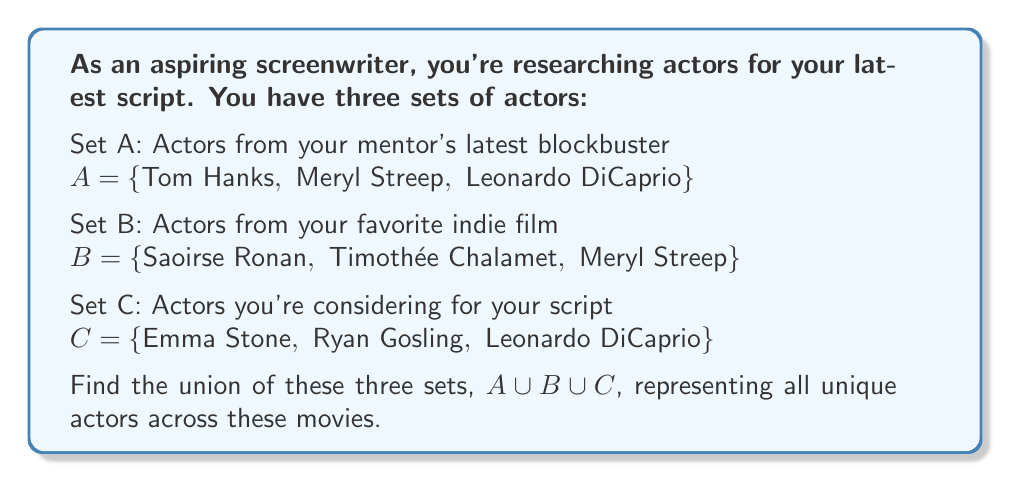Solve this math problem. To find the union of sets A, B, and C, we need to combine all unique elements from these sets. Let's approach this step-by-step:

1. First, let's write out all elements from set A:
   $A = \{$Tom Hanks, Meryl Streep, Leonardo DiCaprio$\}$

2. Now, let's add unique elements from set B:
   - Saoirse Ronan and Timothée Chalamet are new, so we add them.
   - Meryl Streep is already included from set A, so we don't add her again.

3. Finally, let's add unique elements from set C:
   - Emma Stone and Ryan Gosling are new, so we add them.
   - Leonardo DiCaprio is already included from set A, so we don't add him again.

4. The resulting union set contains all unique actors from A, B, and C:

   $A \cup B \cup C = \{$Tom Hanks, Meryl Streep, Leonardo DiCaprio, Saoirse Ronan, Timothée Chalamet, Emma Stone, Ryan Gosling$\}$

5. Count the elements in the union set:
   The union set contains 7 unique actors.

This process demonstrates the union operation in set theory, where we combine all unique elements from multiple sets into a single set.
Answer: $A \cup B \cup C = \{$Tom Hanks, Meryl Streep, Leonardo DiCaprio, Saoirse Ronan, Timothée Chalamet, Emma Stone, Ryan Gosling$\}$ 